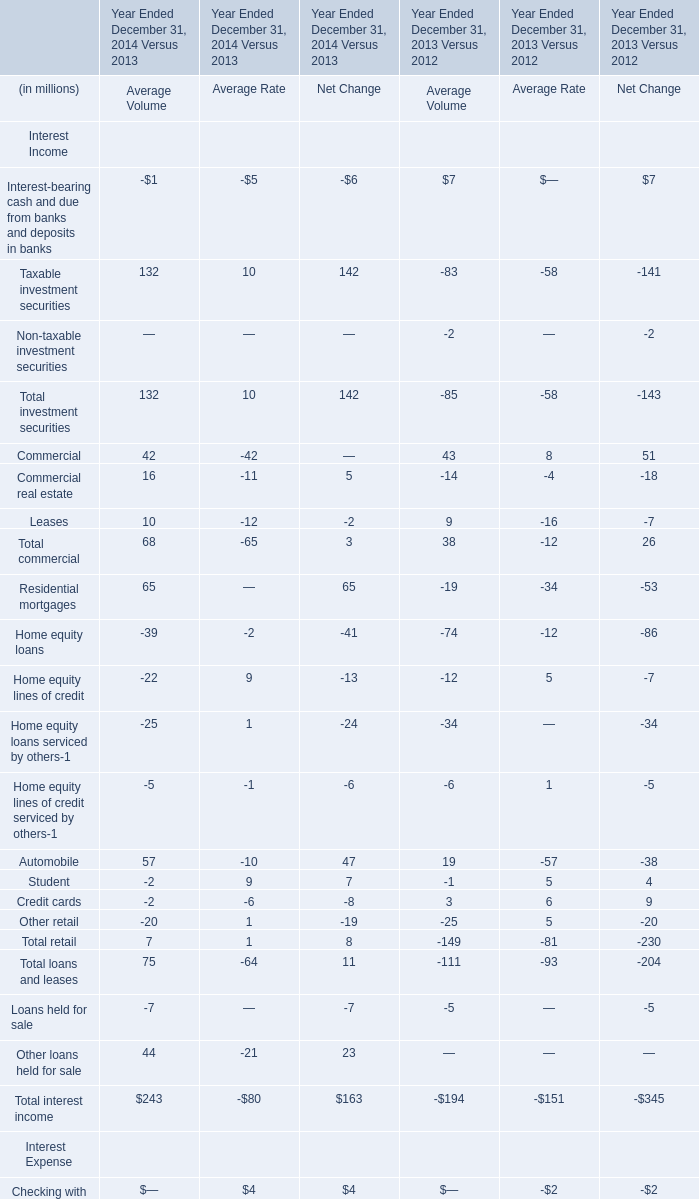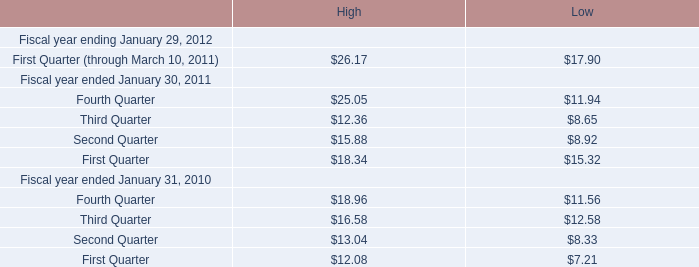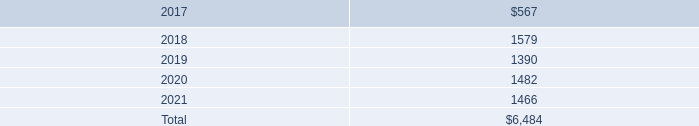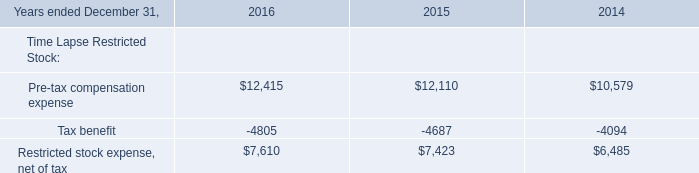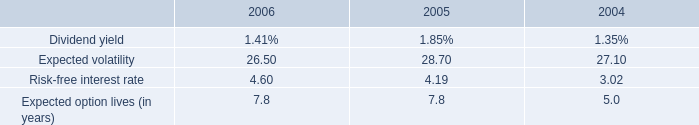what is the growth rate in the risk-free interest rate from 2005 to 2006? 
Computations: ((4.60 - 4.19) / 4.19)
Answer: 0.09785. 